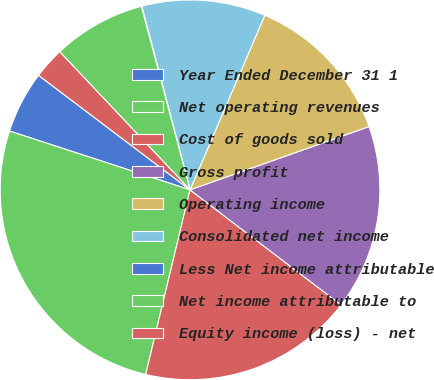Convert chart. <chart><loc_0><loc_0><loc_500><loc_500><pie_chart><fcel>Year Ended December 31 1<fcel>Net operating revenues<fcel>Cost of goods sold<fcel>Gross profit<fcel>Operating income<fcel>Consolidated net income<fcel>Less Net income attributable<fcel>Net income attributable to<fcel>Equity income (loss) - net<nl><fcel>5.29%<fcel>26.26%<fcel>18.39%<fcel>15.77%<fcel>13.15%<fcel>10.53%<fcel>0.04%<fcel>7.91%<fcel>2.66%<nl></chart> 